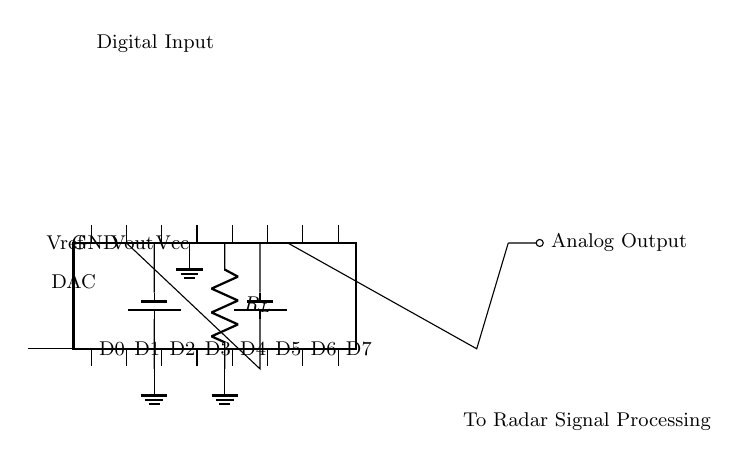What is the number of digital inputs to the DAC? The diagram shows eight digital inputs labeled from D0 to D7, indicating that the DAC has eight inputs in total.
Answer: 8 What is the output voltage of the DAC labeled as? The output voltage from the DAC is labeled Vout, which is derived from the digital inputs and processed by the DAC circuitry.
Answer: Vout What component is connected to the output of the DAC? The output of the DAC connects to a resistor labeled R_L, which suggests a load connected to the DAC output for signal processing.
Answer: R_L What is the reference voltage symbol in the circuit? The symbol for the reference voltage in the circuit diagram is labeled as Vref, which is typically used to set the scale of the output voltage from the DAC.
Answer: Vref Why is there an operational amplifier in the circuit? The operational amplifier is utilized to condition or amplify the output signal from the DAC before it is sent to the radar signal processing. It typically improves the output signal characteristics.
Answer: To amplify the output What is the connection between the Vcc and GND? The circuit shows a connection of Vcc to a battery, reinforcing the supply voltage for the DAC, while GND connects to the negative terminal of the battery, establishing a reference point.
Answer: Battery connection What is the significance of the labeled inputs D0 to D7? The D0 to D7 inputs signify the digital data fed into the DAC; they represent the binary values that will be converted to analog voltage output by the converter.
Answer: Digital data inputs 